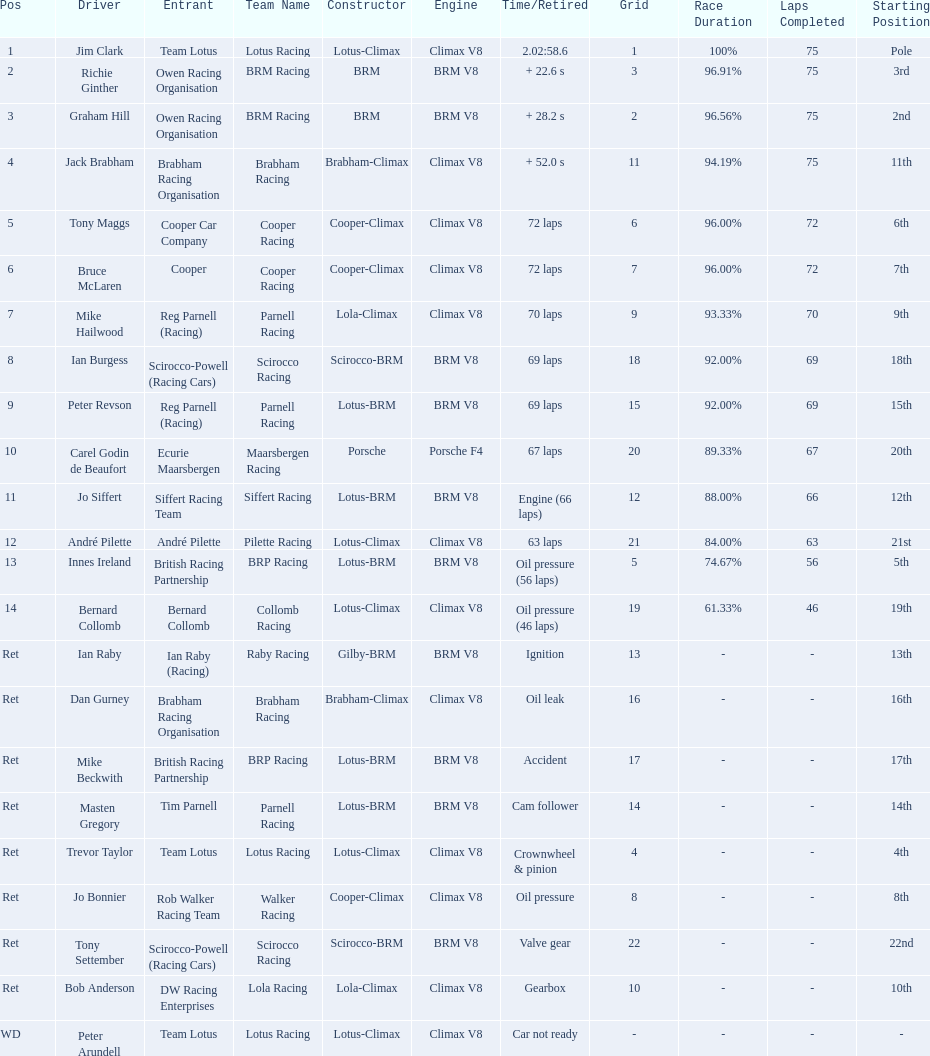What was the same problem that bernard collomb had as innes ireland? Oil pressure. 